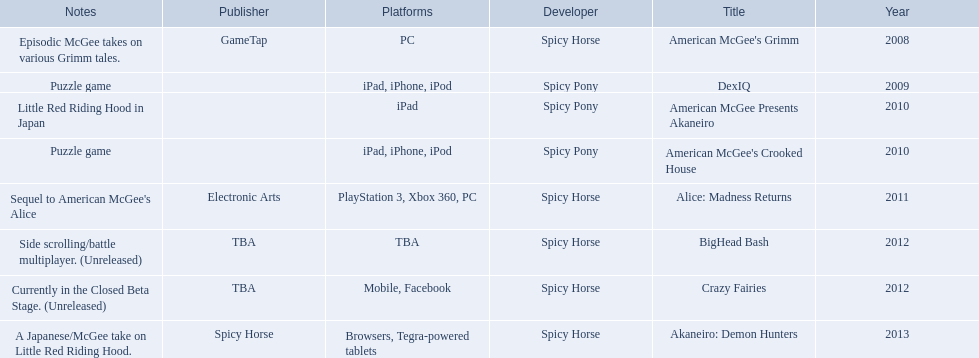What are all the titles of games published? American McGee's Grimm, DexIQ, American McGee Presents Akaneiro, American McGee's Crooked House, Alice: Madness Returns, BigHead Bash, Crazy Fairies, Akaneiro: Demon Hunters. What are all the names of the publishers? GameTap, , , , Electronic Arts, TBA, TBA, Spicy Horse. What is the published game title that corresponds to electronic arts? Alice: Madness Returns. 